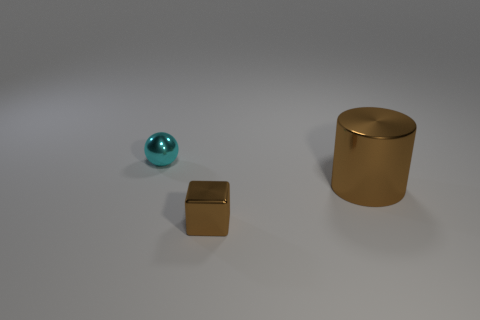Add 3 small metallic things. How many objects exist? 6 Subtract all blocks. How many objects are left? 2 Subtract all tiny brown cubes. Subtract all tiny brown blocks. How many objects are left? 1 Add 1 big shiny cylinders. How many big shiny cylinders are left? 2 Add 1 big shiny cylinders. How many big shiny cylinders exist? 2 Subtract 0 green balls. How many objects are left? 3 